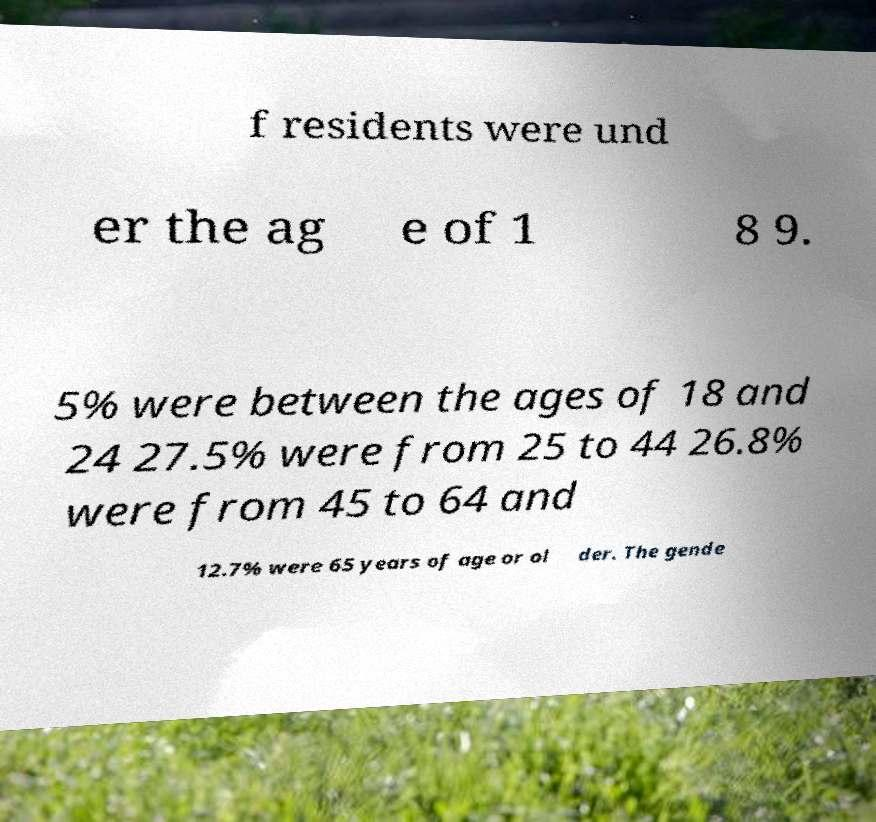I need the written content from this picture converted into text. Can you do that? f residents were und er the ag e of 1 8 9. 5% were between the ages of 18 and 24 27.5% were from 25 to 44 26.8% were from 45 to 64 and 12.7% were 65 years of age or ol der. The gende 